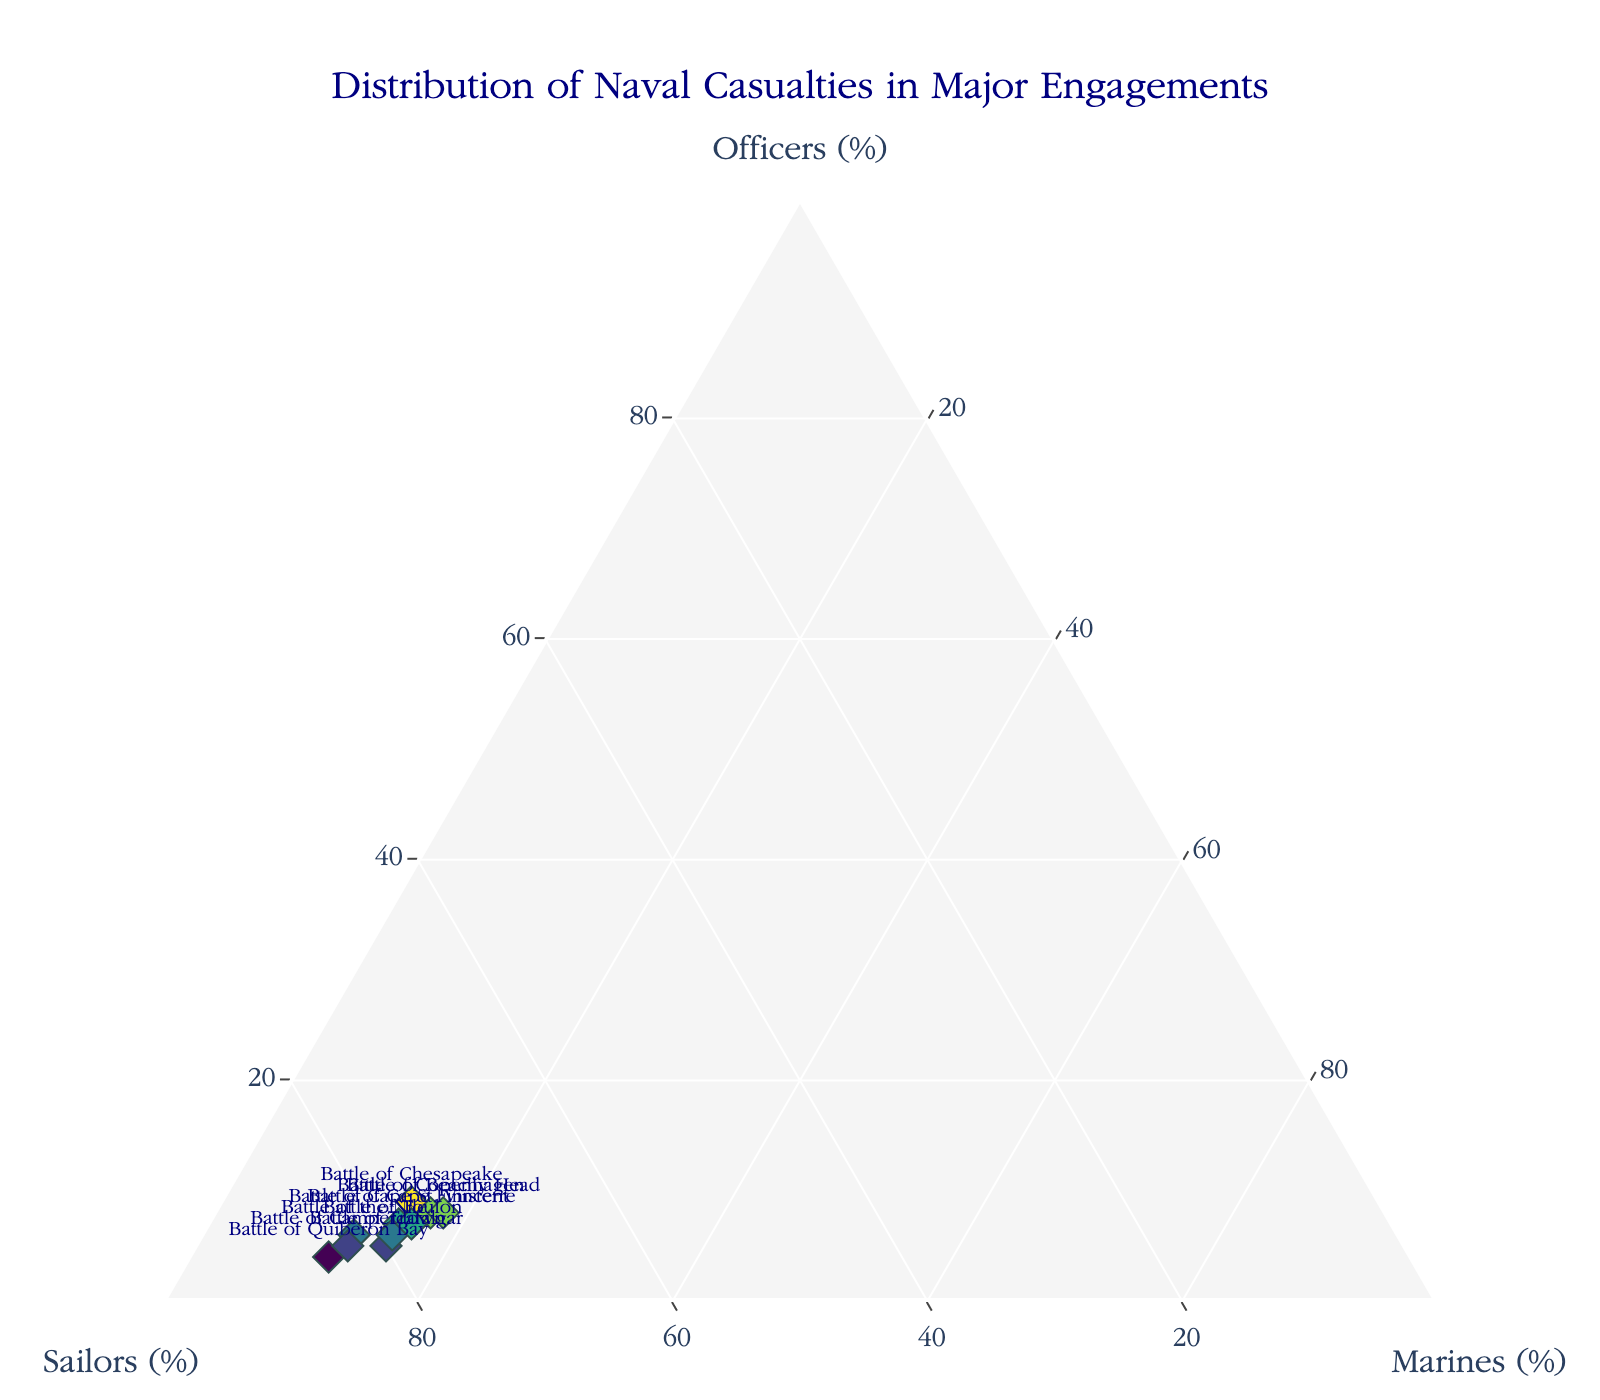What's the title of this ternary plot? The title is displayed at the top center of the plot in large navy font. It reads "Distribution of Naval Casualties in Major Engagements".
Answer: Distribution of Naval Casualties in Major Engagements How many battles are represented in the plot? Each marker on the ternary plot represents a battle. There are 10 markers on the plot.
Answer: 10 Which battle has the highest percentage of officers in casualties? By observing the plot's 'Officers' axis, the marker for the Battle of Chesapeake is positioned closest to the 'Officers' apex, representing 9%.
Answer: Battle of Chesapeake Which battle has the highest percentage of sailors in casualties? The marker closest to the 'Sailors' apex represents the Battle of Quiberon Bay, implying it has the maximum percentage of sailor casualties, which is 85%.
Answer: Battle of Quiberon Bay Which two battles have the same percentage distribution for marines in casualties? By observing the 'Marines' axis, the Battles of Trafalgar, Cape St. Vincent, Chesapeake, Toulon, and Finisterre all lie at the marker of 15%.
Answer: Battle of Trafalgar, Battle of Cape St. Vincent, Battle of Chesapeake, Battle of Toulon, and Battle of Cape Finisterre Between the Battle of Trafalgar and the Battle of Camperdown, which one has a higher percentage of marine casualties? By examining the plot, the marker for the Battle of Trafalgar lies at 15% for marines, whereas the marker for the Battle of Camperdown is at 12% for marines.
Answer: Battle of Trafalgar What is the average percentage of sailors in casualties across all the major battles represented? The sailors' percentages are 80, 75, 82, 78, 85, 76, 79, 83, 77, and 74. Calculating the average: (80 + 75 + 82 + 78 + 85 + 76 + 79 + 83 + 77 + 74) / 10 = 78.9
Answer: 78.9 Which battle has the most balanced distribution of casualties among officers, sailors, and marines? Look for a point that is more central in the plot. Battle of Beachy Head has a nearly equal distribution with 8% officers, 74% sailors, and 18% marines.
Answer: Battle of Beachy Head How does the percentage of sailors in the Battle of Copenhagen compare with that in the Battle of the Nile? The Battle of Copenhagen has 75% sailors, while the Battle of the Nile has 82%. Comparatively, the Battle of the Nile has a higher sailor percentage by 7%.
Answer: Battle of the Nile has 7% more Which battle had the lowest percentage of officers in casualties among all battles represented? By observing the 'Officers' axis, the Battle of Quiberon Bay is closest to the base, indicating the lowest percentage of officers at 4%.
Answer: Battle of Quiberon Bay 